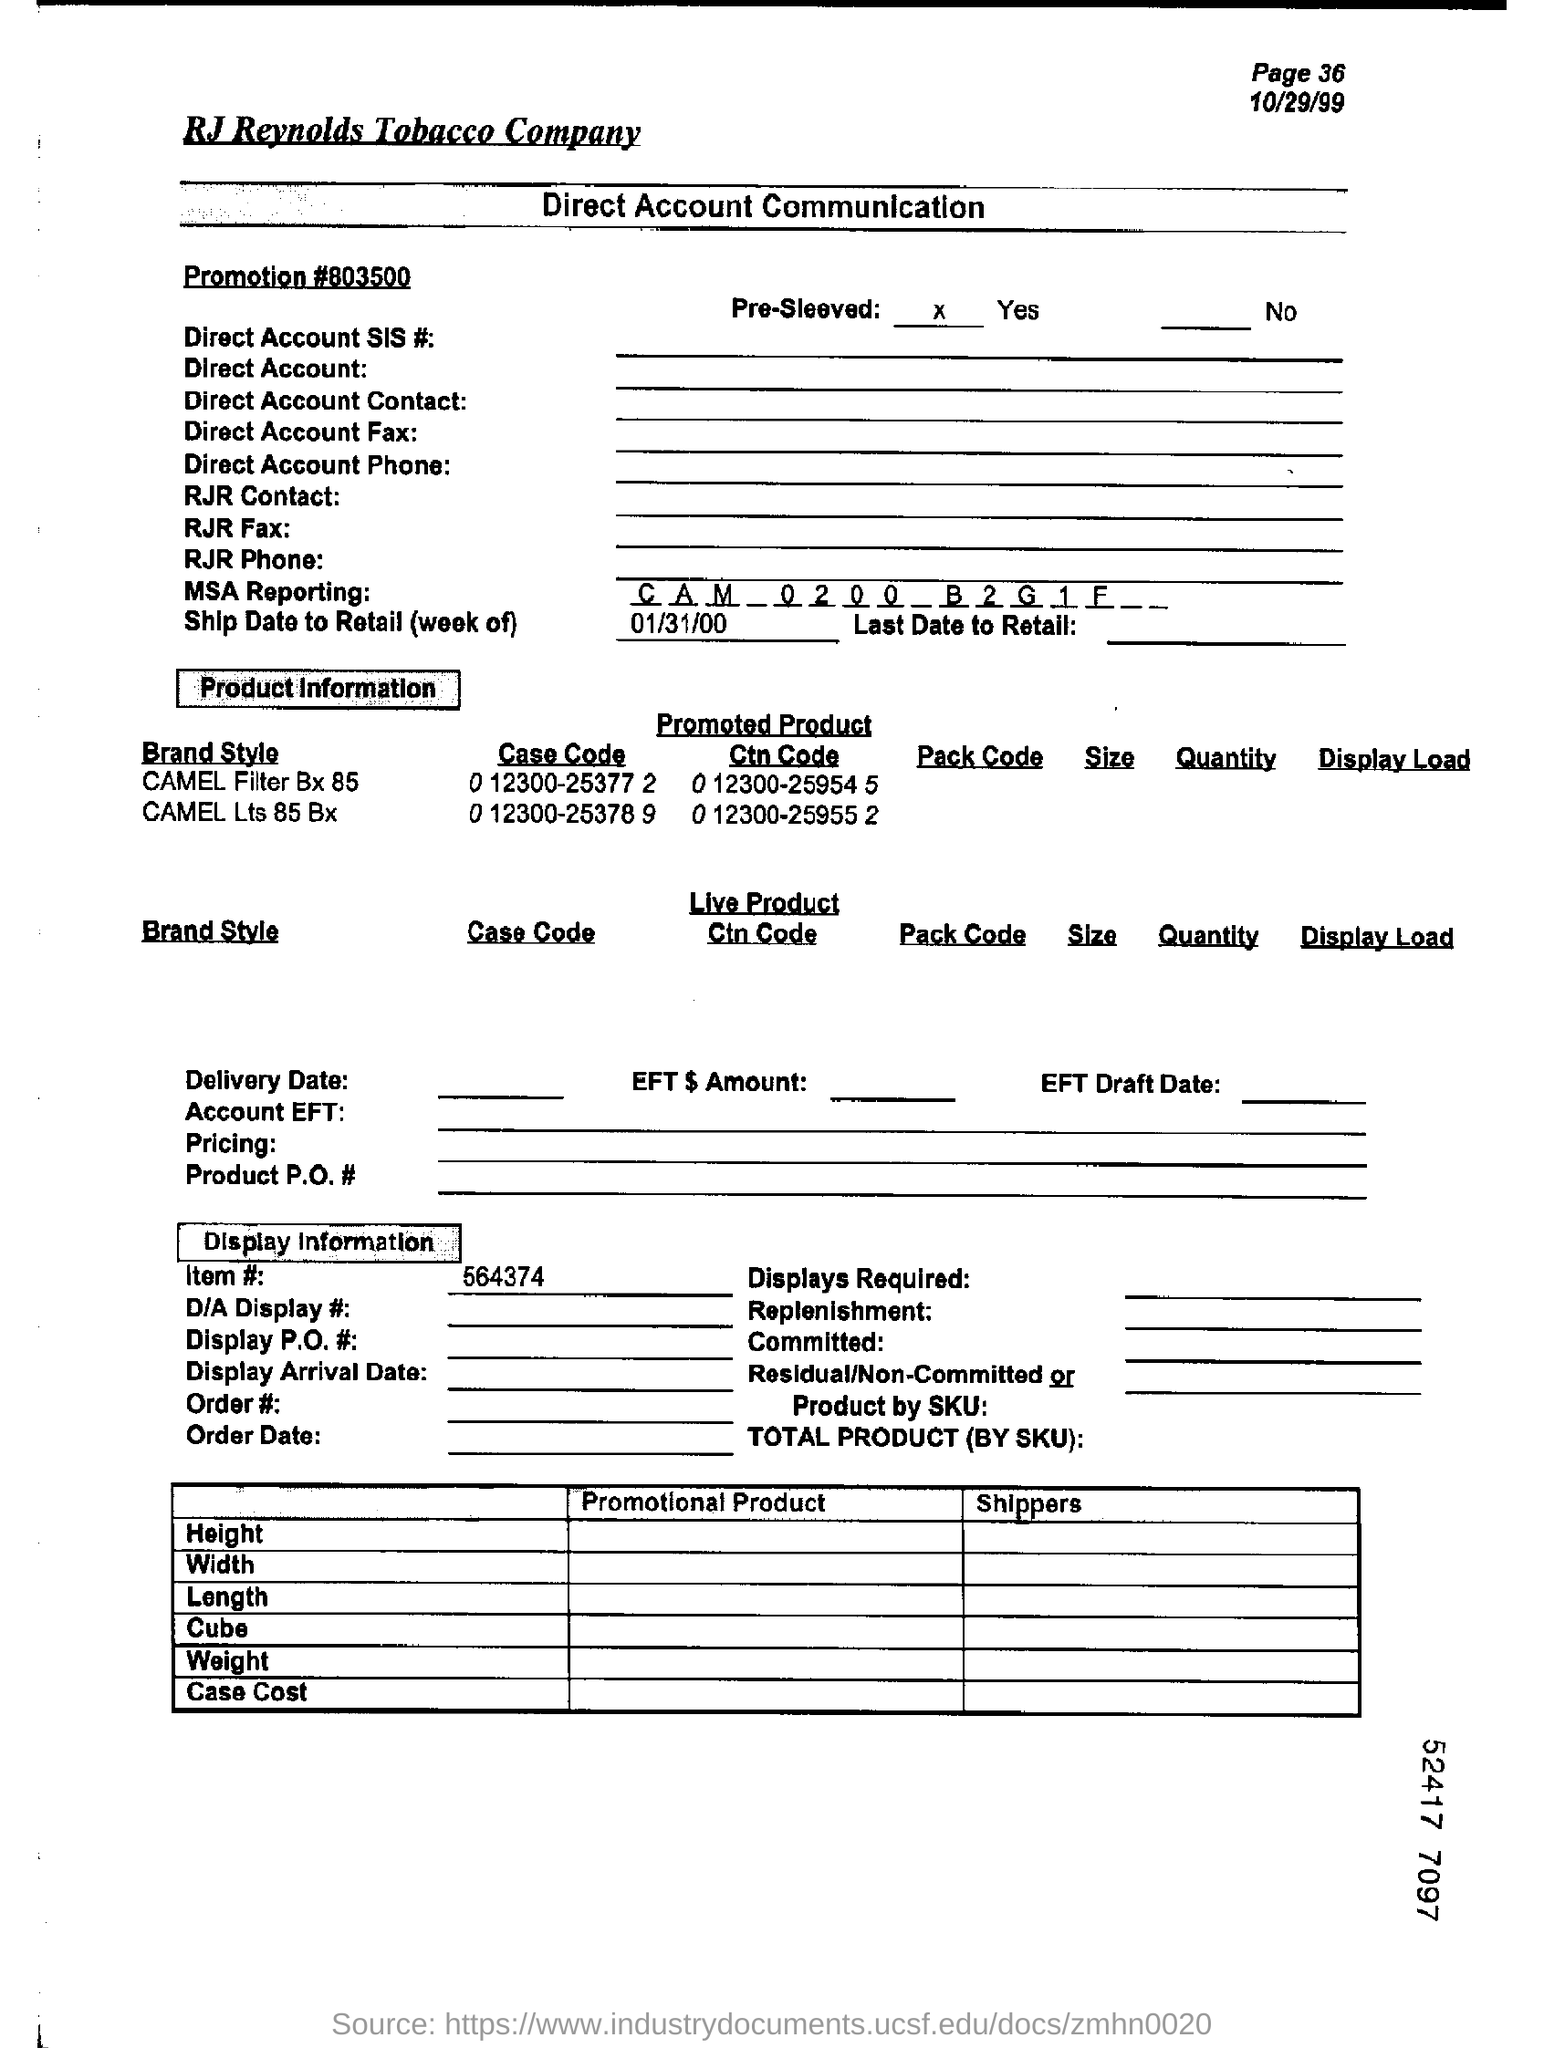Highlight a few significant elements in this photo. The case code of the CAMEL Filter Bx 85 is 0 12300-25377 2. The promoted product CTN code of CAMEL LTS 85 BX is 0 12300-25955 2. The page number is 36, as declared. The item number is 564374... The MSA reporting is a process in which a company provides detailed information on its business activities and financial performance to various stakeholders, including regulatory agencies, investors, and the general public. 